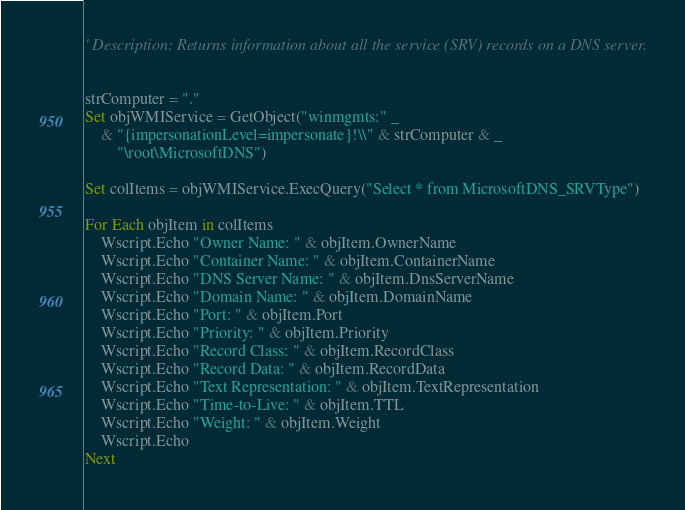Convert code to text. <code><loc_0><loc_0><loc_500><loc_500><_VisualBasic_>' Description: Returns information about all the service (SRV) records on a DNS server.


strComputer = "."
Set objWMIService = GetObject("winmgmts:" _
    & "{impersonationLevel=impersonate}!\\" & strComputer & _
        "\root\MicrosoftDNS")

Set colItems = objWMIService.ExecQuery("Select * from MicrosoftDNS_SRVType")

For Each objItem in colItems
    Wscript.Echo "Owner Name: " & objItem.OwnerName
    Wscript.Echo "Container Name: " & objItem.ContainerName
    Wscript.Echo "DNS Server Name: " & objItem.DnsServerName
    Wscript.Echo "Domain Name: " & objItem.DomainName
    Wscript.Echo "Port: " & objItem.Port
    Wscript.Echo "Priority: " & objItem.Priority
    Wscript.Echo "Record Class: " & objItem.RecordClass
    Wscript.Echo "Record Data: " & objItem.RecordData
    Wscript.Echo "Text Representation: " & objItem.TextRepresentation
    Wscript.Echo "Time-to-Live: " & objItem.TTL
    Wscript.Echo "Weight: " & objItem.Weight
    Wscript.Echo
Next

</code> 